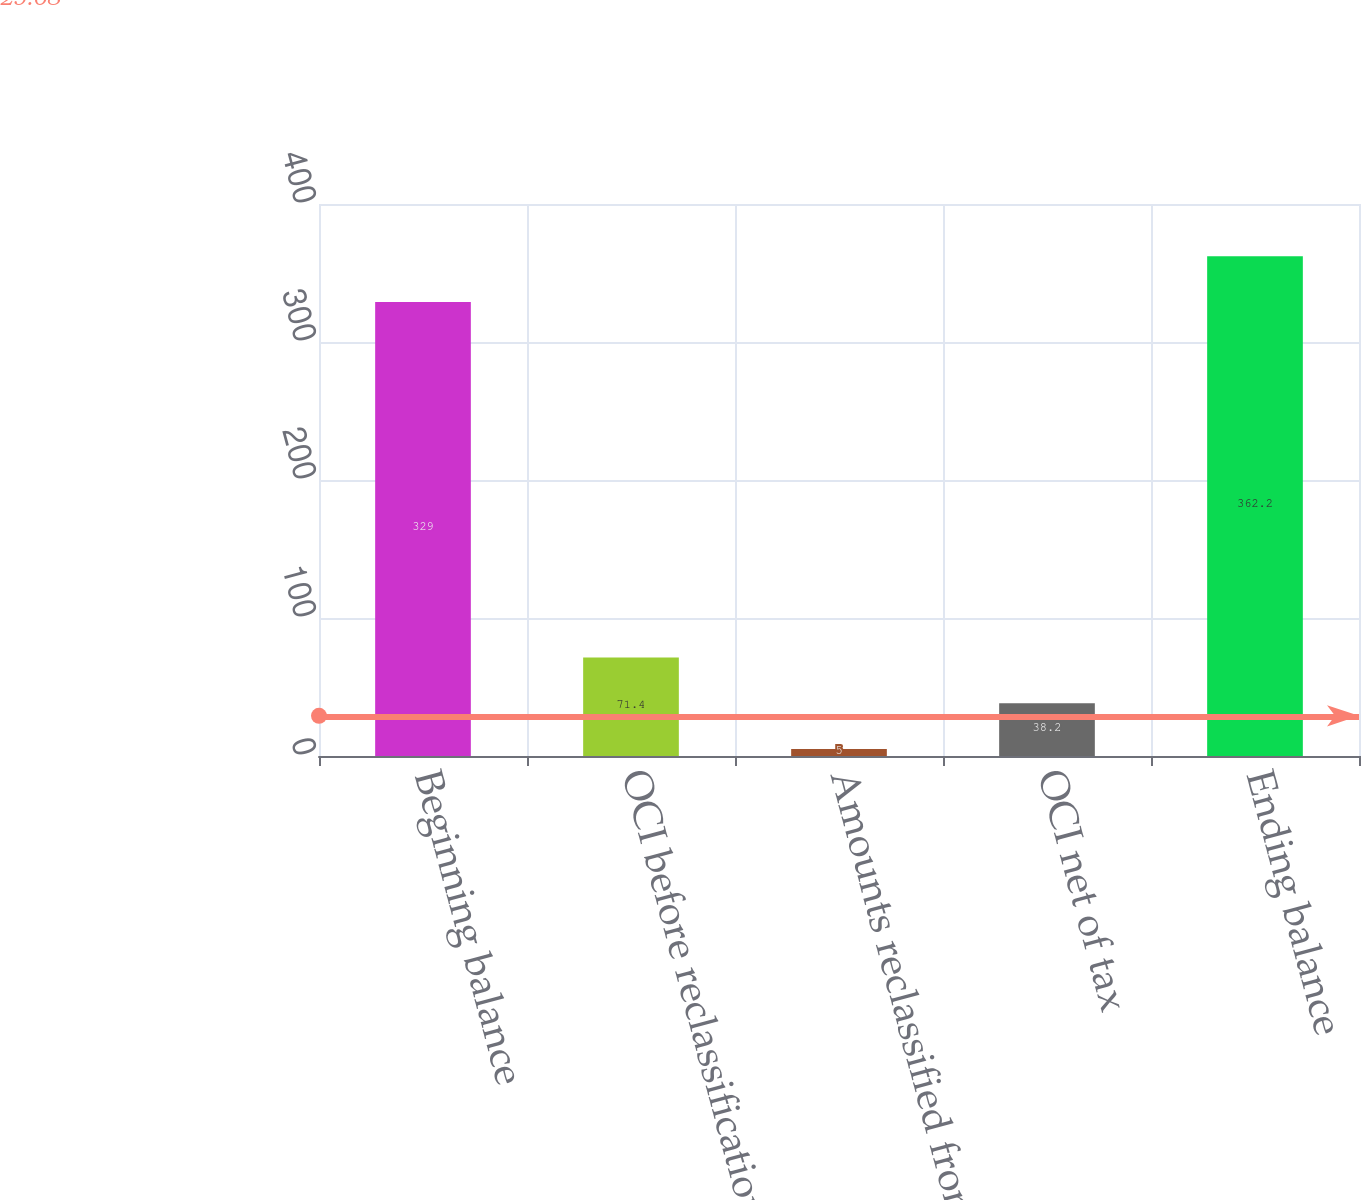Convert chart to OTSL. <chart><loc_0><loc_0><loc_500><loc_500><bar_chart><fcel>Beginning balance<fcel>OCI before reclassifications<fcel>Amounts reclassified from AOCI<fcel>OCI net of tax<fcel>Ending balance<nl><fcel>329<fcel>71.4<fcel>5<fcel>38.2<fcel>362.2<nl></chart> 